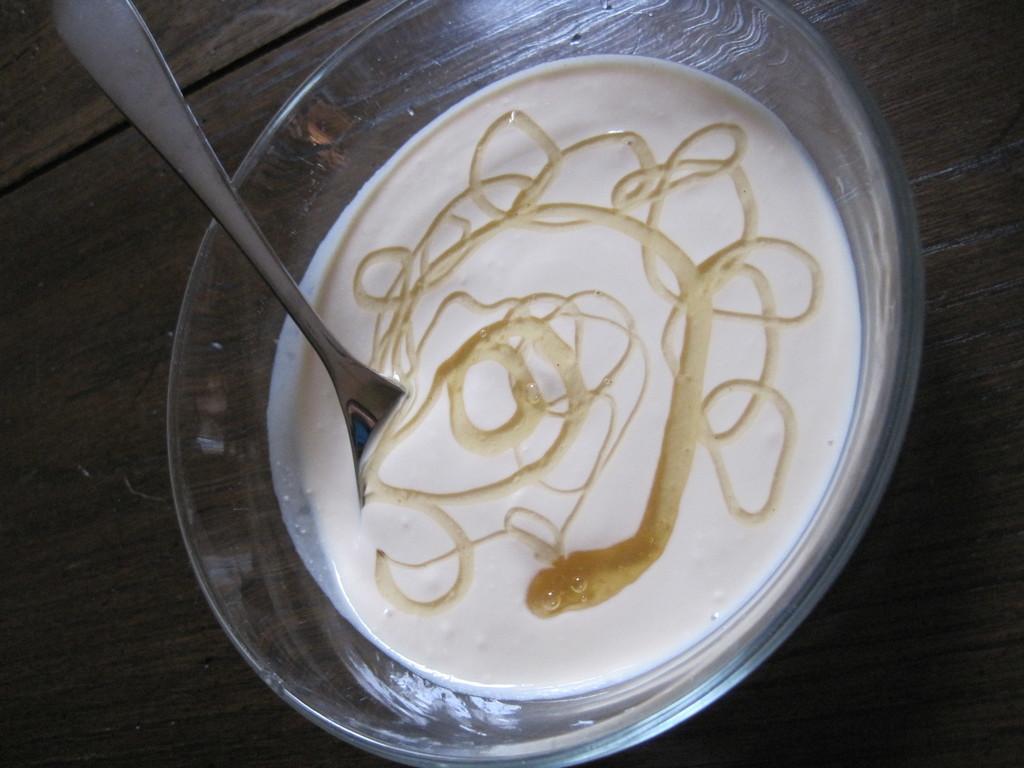Could you give a brief overview of what you see in this image? In this image I can see the glass bowl with food and the spoon. It is on the brown color surface. 